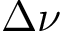Convert formula to latex. <formula><loc_0><loc_0><loc_500><loc_500>\Delta \nu</formula> 